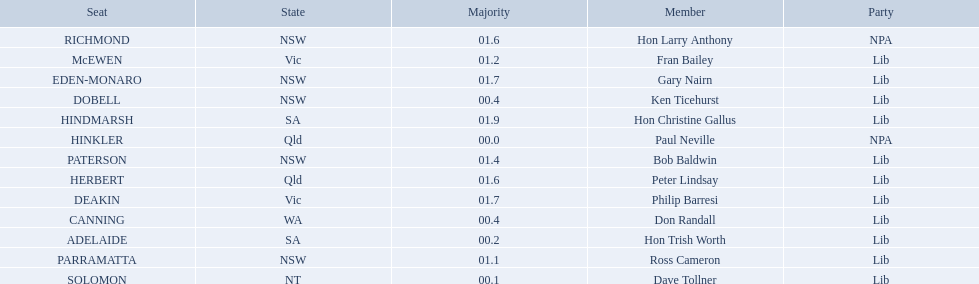What state does hinkler belong too? Qld. What is the majority of difference between sa and qld? 01.9. 